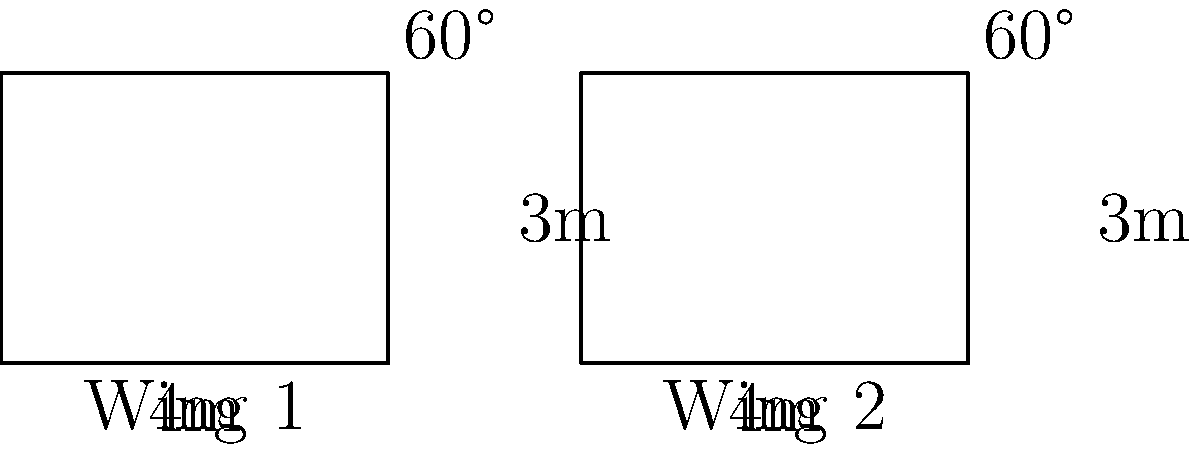As a test pilot, you're evaluating two aircraft wings for potential use in a new military aircraft. Both wings have a length of 4m and a width of 3m. The angle between the leading edge and the wingtip is 60° for both wings. Based on these measurements, are the two wings congruent? Justify your answer. To determine if the two wings are congruent, we need to compare their corresponding sides and angles. Let's analyze the given information step by step:

1. Side lengths:
   - Wing 1: Length = 4m, Width = 3m
   - Wing 2: Length = 4m, Width = 3m
   The corresponding sides are equal.

2. Angles:
   - Wing 1: Angle between leading edge and wingtip = 60°
   - Wing 2: Angle between leading edge and wingtip = 60°
   The corresponding angles are equal.

3. Shape:
   Both wings appear to be right triangles with a rectangular base.

4. Congruence criteria:
   For two triangles to be congruent, they must satisfy one of the following criteria:
   - SSS (Side-Side-Side): All three corresponding sides are equal
   - SAS (Side-Angle-Side): Two corresponding sides and the included angle are equal
   - ASA (Angle-Side-Angle): Two corresponding angles and the included side are equal

In this case, we have:
- Two corresponding sides equal (4m and 3m)
- One corresponding angle equal (60°)
- The right angle formed by the length and width (90°)

This satisfies the SAS (Side-Angle-Side) congruence criterion.

Therefore, based on the given measurements and the SAS congruence criterion, we can conclude that the two wings are congruent.
Answer: Yes, the wings are congruent (SAS criterion). 